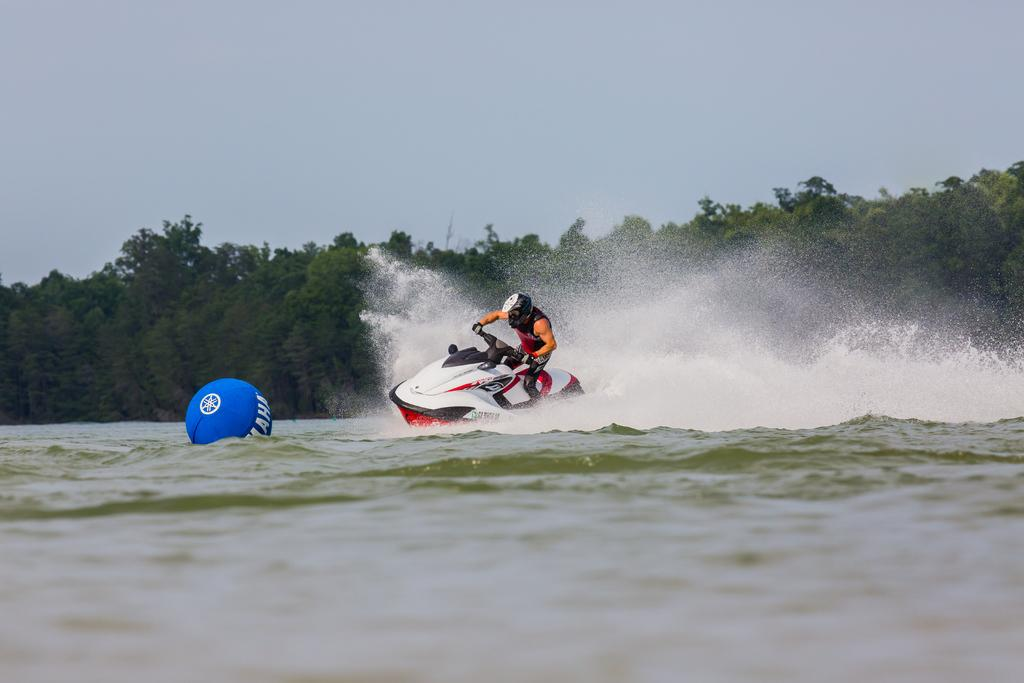What activity is the person in the image engaged in? The person is riding on a jet ski in the image. Where is the jet ski located? The jet ski is on a river in the image. What object with text can be seen in the image? There is a ball with text on it in the image. What type of vegetation is visible in the image? There are trees visible in the image. What part of the natural environment is visible in the image? The sky is visible in the image. What type of collar can be seen on the honey in the image? There is no honey or collar present in the image. How many crayons are visible in the image? There are no crayons present in the image. 